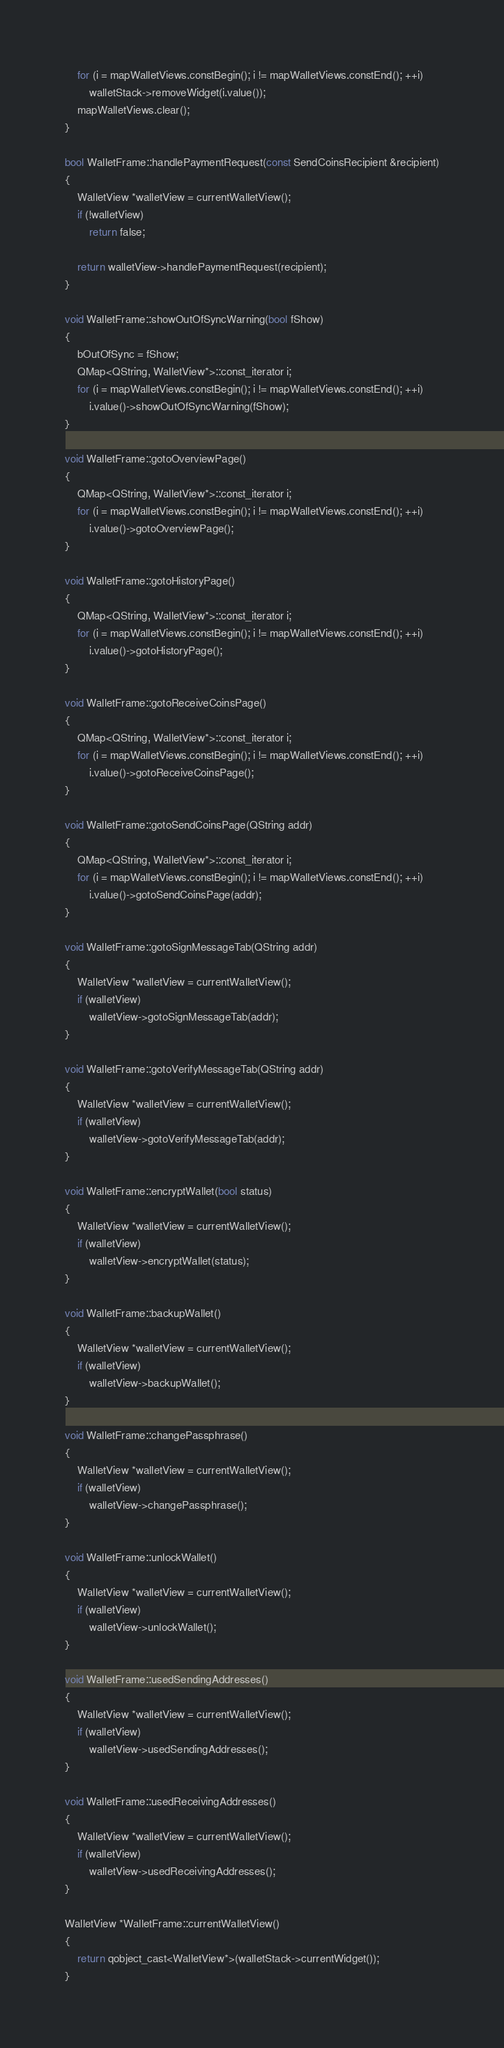Convert code to text. <code><loc_0><loc_0><loc_500><loc_500><_C++_>    for (i = mapWalletViews.constBegin(); i != mapWalletViews.constEnd(); ++i)
        walletStack->removeWidget(i.value());
    mapWalletViews.clear();
}

bool WalletFrame::handlePaymentRequest(const SendCoinsRecipient &recipient)
{
    WalletView *walletView = currentWalletView();
    if (!walletView)
        return false;

    return walletView->handlePaymentRequest(recipient);
}

void WalletFrame::showOutOfSyncWarning(bool fShow)
{
    bOutOfSync = fShow;
    QMap<QString, WalletView*>::const_iterator i;
    for (i = mapWalletViews.constBegin(); i != mapWalletViews.constEnd(); ++i)
        i.value()->showOutOfSyncWarning(fShow);
}

void WalletFrame::gotoOverviewPage()
{
    QMap<QString, WalletView*>::const_iterator i;
    for (i = mapWalletViews.constBegin(); i != mapWalletViews.constEnd(); ++i)
        i.value()->gotoOverviewPage();
}

void WalletFrame::gotoHistoryPage()
{
    QMap<QString, WalletView*>::const_iterator i;
    for (i = mapWalletViews.constBegin(); i != mapWalletViews.constEnd(); ++i)
        i.value()->gotoHistoryPage();
}

void WalletFrame::gotoReceiveCoinsPage()
{
    QMap<QString, WalletView*>::const_iterator i;
    for (i = mapWalletViews.constBegin(); i != mapWalletViews.constEnd(); ++i)
        i.value()->gotoReceiveCoinsPage();
}

void WalletFrame::gotoSendCoinsPage(QString addr)
{
    QMap<QString, WalletView*>::const_iterator i;
    for (i = mapWalletViews.constBegin(); i != mapWalletViews.constEnd(); ++i)
        i.value()->gotoSendCoinsPage(addr);
}

void WalletFrame::gotoSignMessageTab(QString addr)
{
    WalletView *walletView = currentWalletView();
    if (walletView)
        walletView->gotoSignMessageTab(addr);
}

void WalletFrame::gotoVerifyMessageTab(QString addr)
{
    WalletView *walletView = currentWalletView();
    if (walletView)
        walletView->gotoVerifyMessageTab(addr);
}

void WalletFrame::encryptWallet(bool status)
{
    WalletView *walletView = currentWalletView();
    if (walletView)
        walletView->encryptWallet(status);
}

void WalletFrame::backupWallet()
{
    WalletView *walletView = currentWalletView();
    if (walletView)
        walletView->backupWallet();
}

void WalletFrame::changePassphrase()
{
    WalletView *walletView = currentWalletView();
    if (walletView)
        walletView->changePassphrase();
}

void WalletFrame::unlockWallet()
{
    WalletView *walletView = currentWalletView();
    if (walletView)
        walletView->unlockWallet();
}

void WalletFrame::usedSendingAddresses()
{
    WalletView *walletView = currentWalletView();
    if (walletView)
        walletView->usedSendingAddresses();
}

void WalletFrame::usedReceivingAddresses()
{
    WalletView *walletView = currentWalletView();
    if (walletView)
        walletView->usedReceivingAddresses();
}

WalletView *WalletFrame::currentWalletView()
{
    return qobject_cast<WalletView*>(walletStack->currentWidget());
}

</code> 